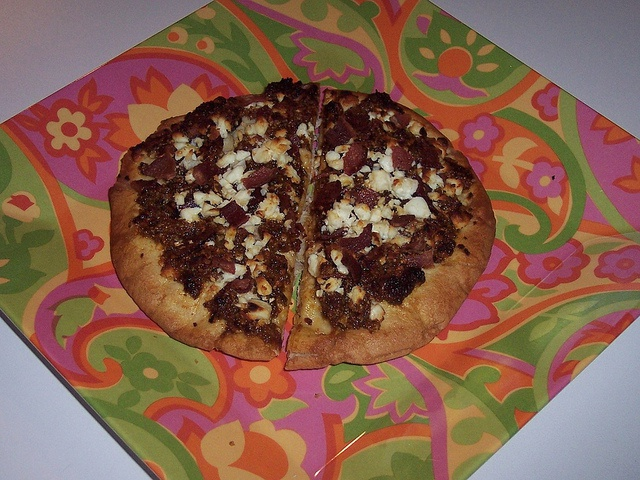Describe the objects in this image and their specific colors. I can see dining table in brown, olive, black, and maroon tones and pizza in gray, black, maroon, and brown tones in this image. 